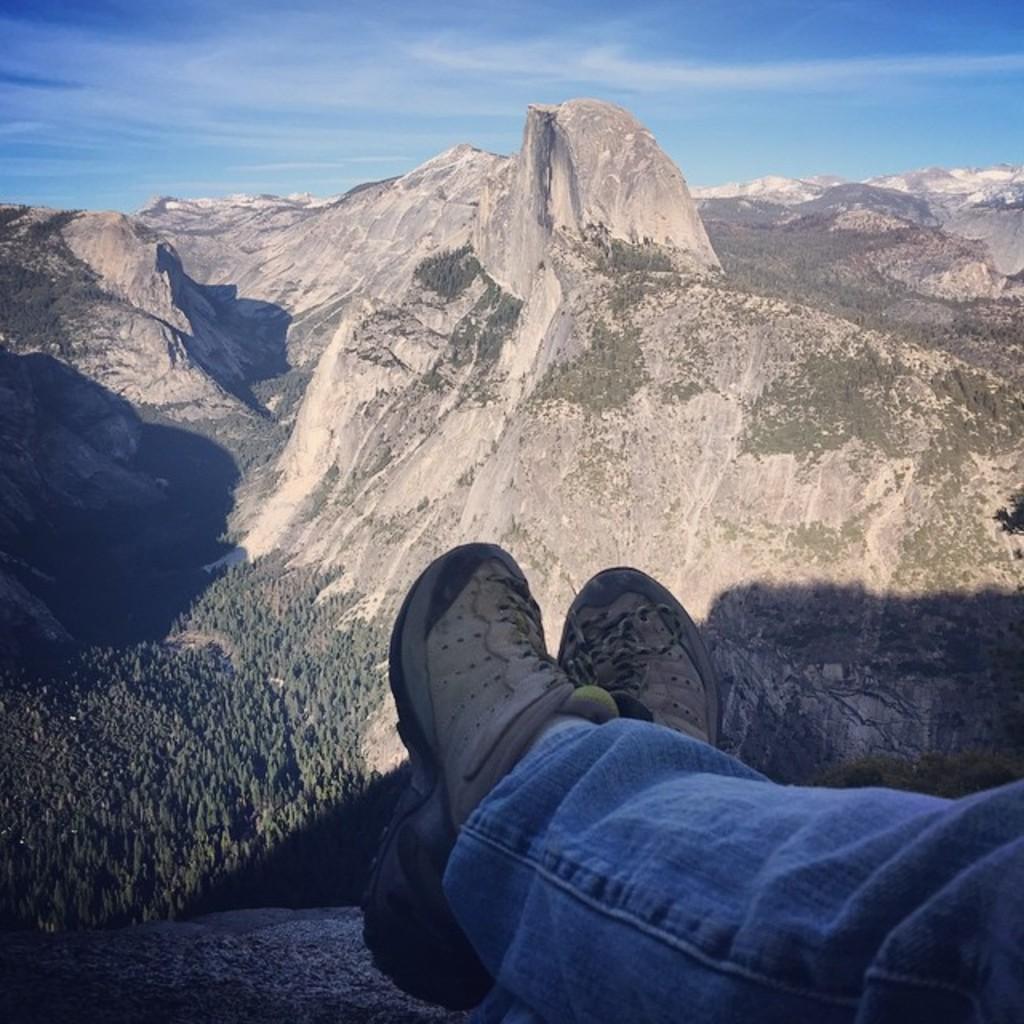In one or two sentences, can you explain what this image depicts? In this picture there are two legs at the bottom side of the image, there is greenery in the image and there are mountains in the background area of the image. 